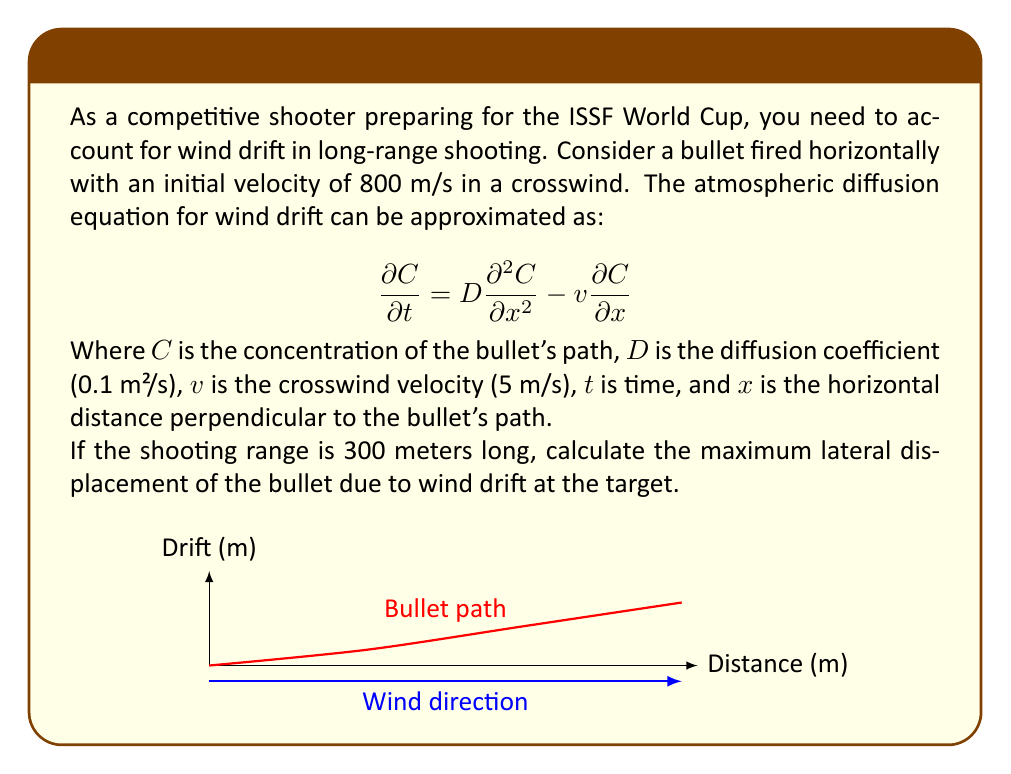Provide a solution to this math problem. To solve this problem, we'll follow these steps:

1) First, we need to calculate the time it takes for the bullet to reach the target:
   $$t = \frac{\text{distance}}{\text{velocity}} = \frac{300 \text{ m}}{800 \text{ m/s}} = 0.375 \text{ s}$$

2) The solution to the atmospheric diffusion equation for an instantaneous point source (which we can approximate our bullet as) is:

   $$C(x,t) = \frac{1}{\sqrt{4\pi Dt}} \exp\left(-\frac{(x-vt)^2}{4Dt}\right)$$

3) The maximum lateral displacement occurs where $\frac{\partial C}{\partial x} = 0$. This happens when $x = vt$.

4) Therefore, the maximum lateral displacement is:
   $$x = vt = (5 \text{ m/s})(0.375 \text{ s}) = 1.875 \text{ m}$$

5) We can verify this by plotting the concentration distribution at t = 0.375 s:

   $$C(x,0.375) = \frac{1}{\sqrt{4\pi(0.1)(0.375)}} \exp\left(-\frac{(x-1.875)^2}{4(0.1)(0.375)}\right)$$

   The peak of this distribution occurs at x = 1.875 m.
Answer: 1.875 m 